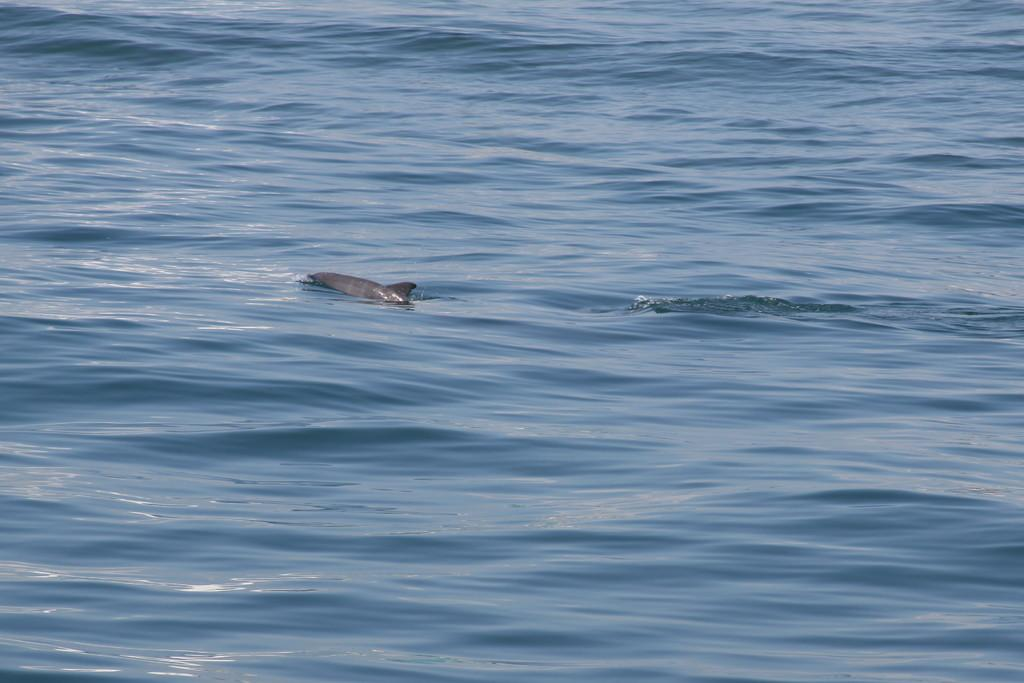What is the primary element in the image? There is water in the image. What can be seen swimming in the water? A fish is swimming in the water. What type of steel is being used to create the copy of the fish in the image? There is no steel or copy of the fish present in the image; it features a fish swimming in water. 